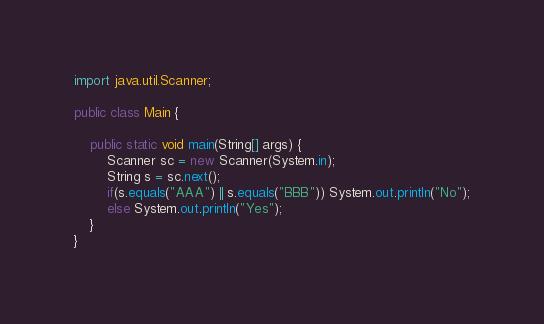<code> <loc_0><loc_0><loc_500><loc_500><_Java_>import java.util.Scanner;

public class Main {

    public static void main(String[] args) {
        Scanner sc = new Scanner(System.in);
        String s = sc.next();
        if(s.equals("AAA") || s.equals("BBB")) System.out.println("No");
        else System.out.println("Yes");
    }
}
</code> 